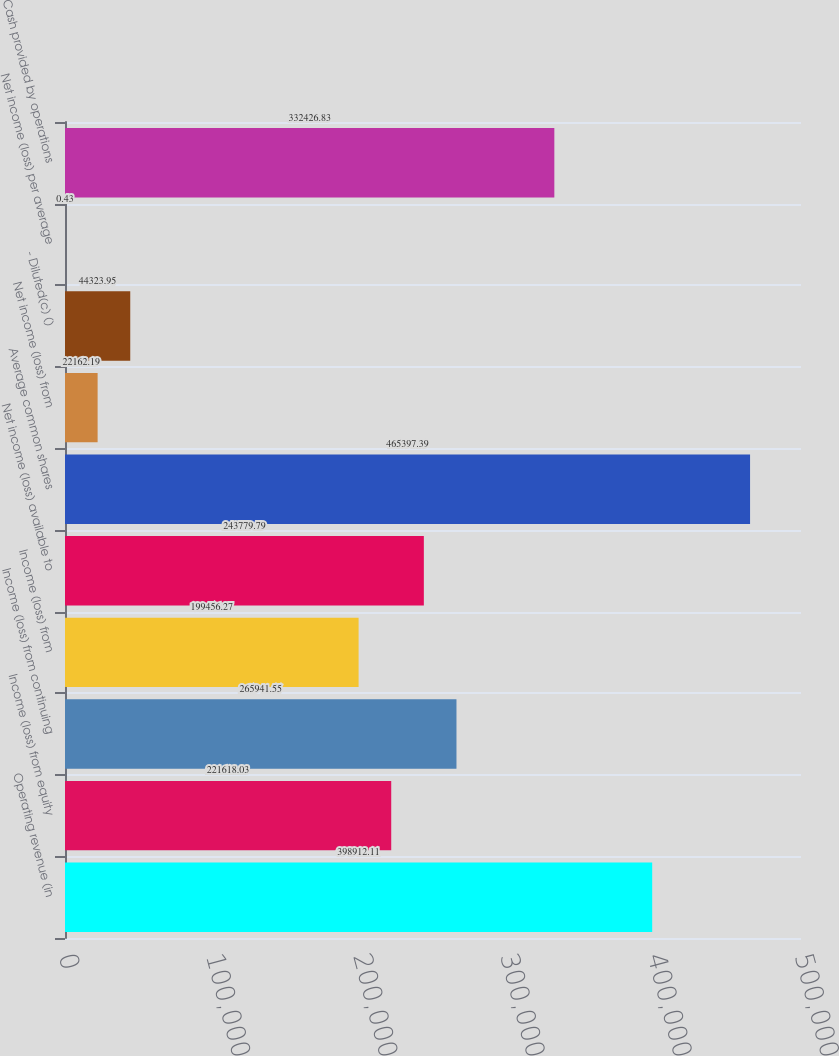<chart> <loc_0><loc_0><loc_500><loc_500><bar_chart><fcel>Operating revenue (in<fcel>Income (loss) from equity<fcel>Income (loss) from continuing<fcel>Income (loss) from<fcel>Net income (loss) available to<fcel>Average common shares<fcel>Net income (loss) from<fcel>- Diluted(c) ()<fcel>Net income (loss) per average<fcel>Cash provided by operations<nl><fcel>398912<fcel>221618<fcel>265942<fcel>199456<fcel>243780<fcel>465397<fcel>22162.2<fcel>44323.9<fcel>0.43<fcel>332427<nl></chart> 